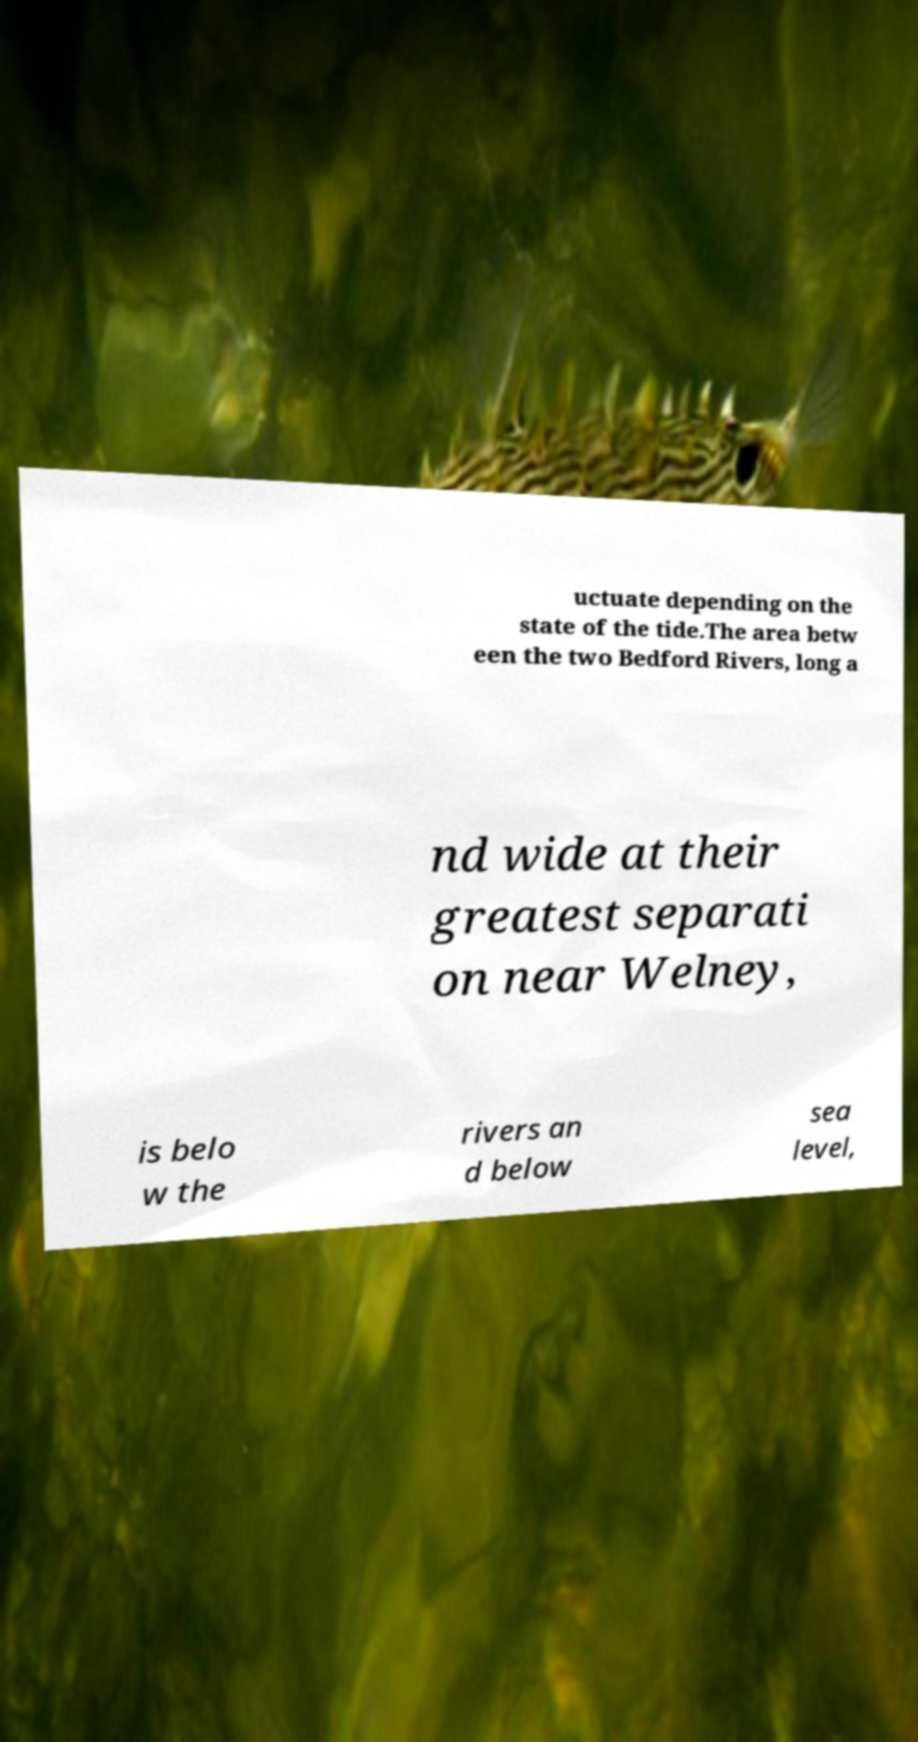What messages or text are displayed in this image? I need them in a readable, typed format. uctuate depending on the state of the tide.The area betw een the two Bedford Rivers, long a nd wide at their greatest separati on near Welney, is belo w the rivers an d below sea level, 